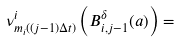<formula> <loc_0><loc_0><loc_500><loc_500>\nu ^ { i } _ { m _ { i } ( ( j - 1 ) \Delta t ) } \left ( B ^ { \delta } _ { i , j - 1 } ( a ) \right ) =</formula> 